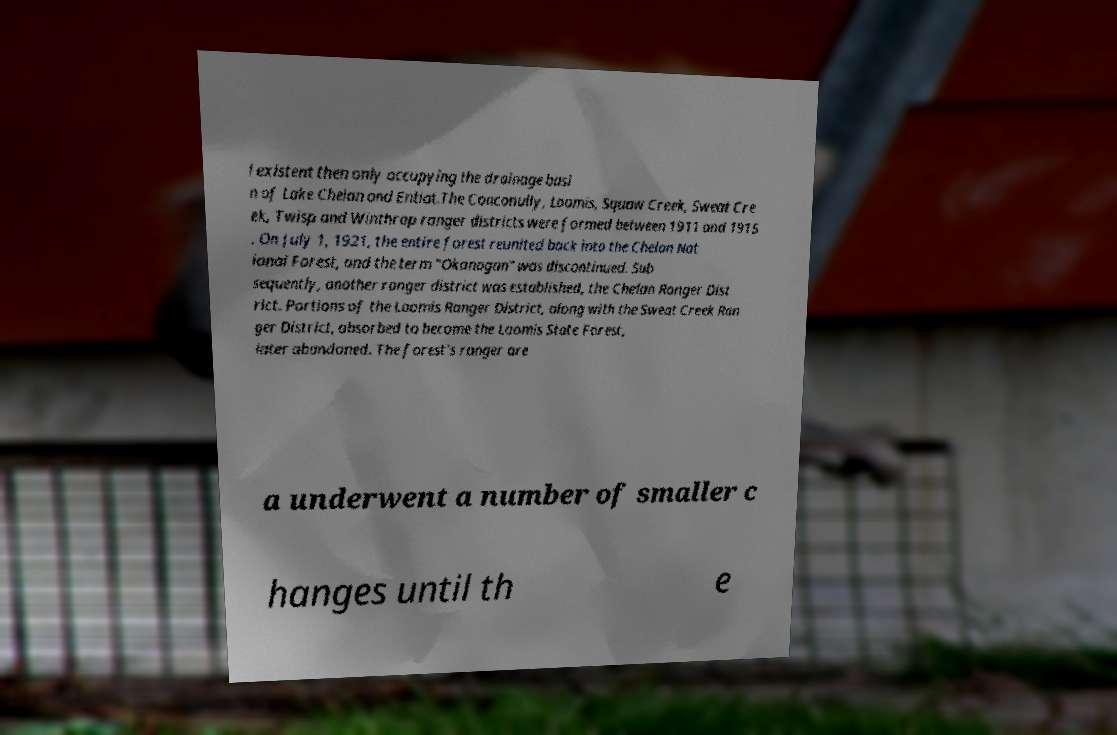Please read and relay the text visible in this image. What does it say? l existent then only occupying the drainage basi n of Lake Chelan and Entiat.The Conconully, Loomis, Squaw Creek, Sweat Cre ek, Twisp and Winthrop ranger districts were formed between 1911 and 1915 . On July 1, 1921, the entire forest reunited back into the Chelan Nat ional Forest, and the term "Okanogan" was discontinued. Sub sequently, another ranger district was established, the Chelan Ranger Dist rict. Portions of the Loomis Ranger District, along with the Sweat Creek Ran ger District, absorbed to become the Loomis State Forest, later abandoned. The forest's ranger are a underwent a number of smaller c hanges until th e 